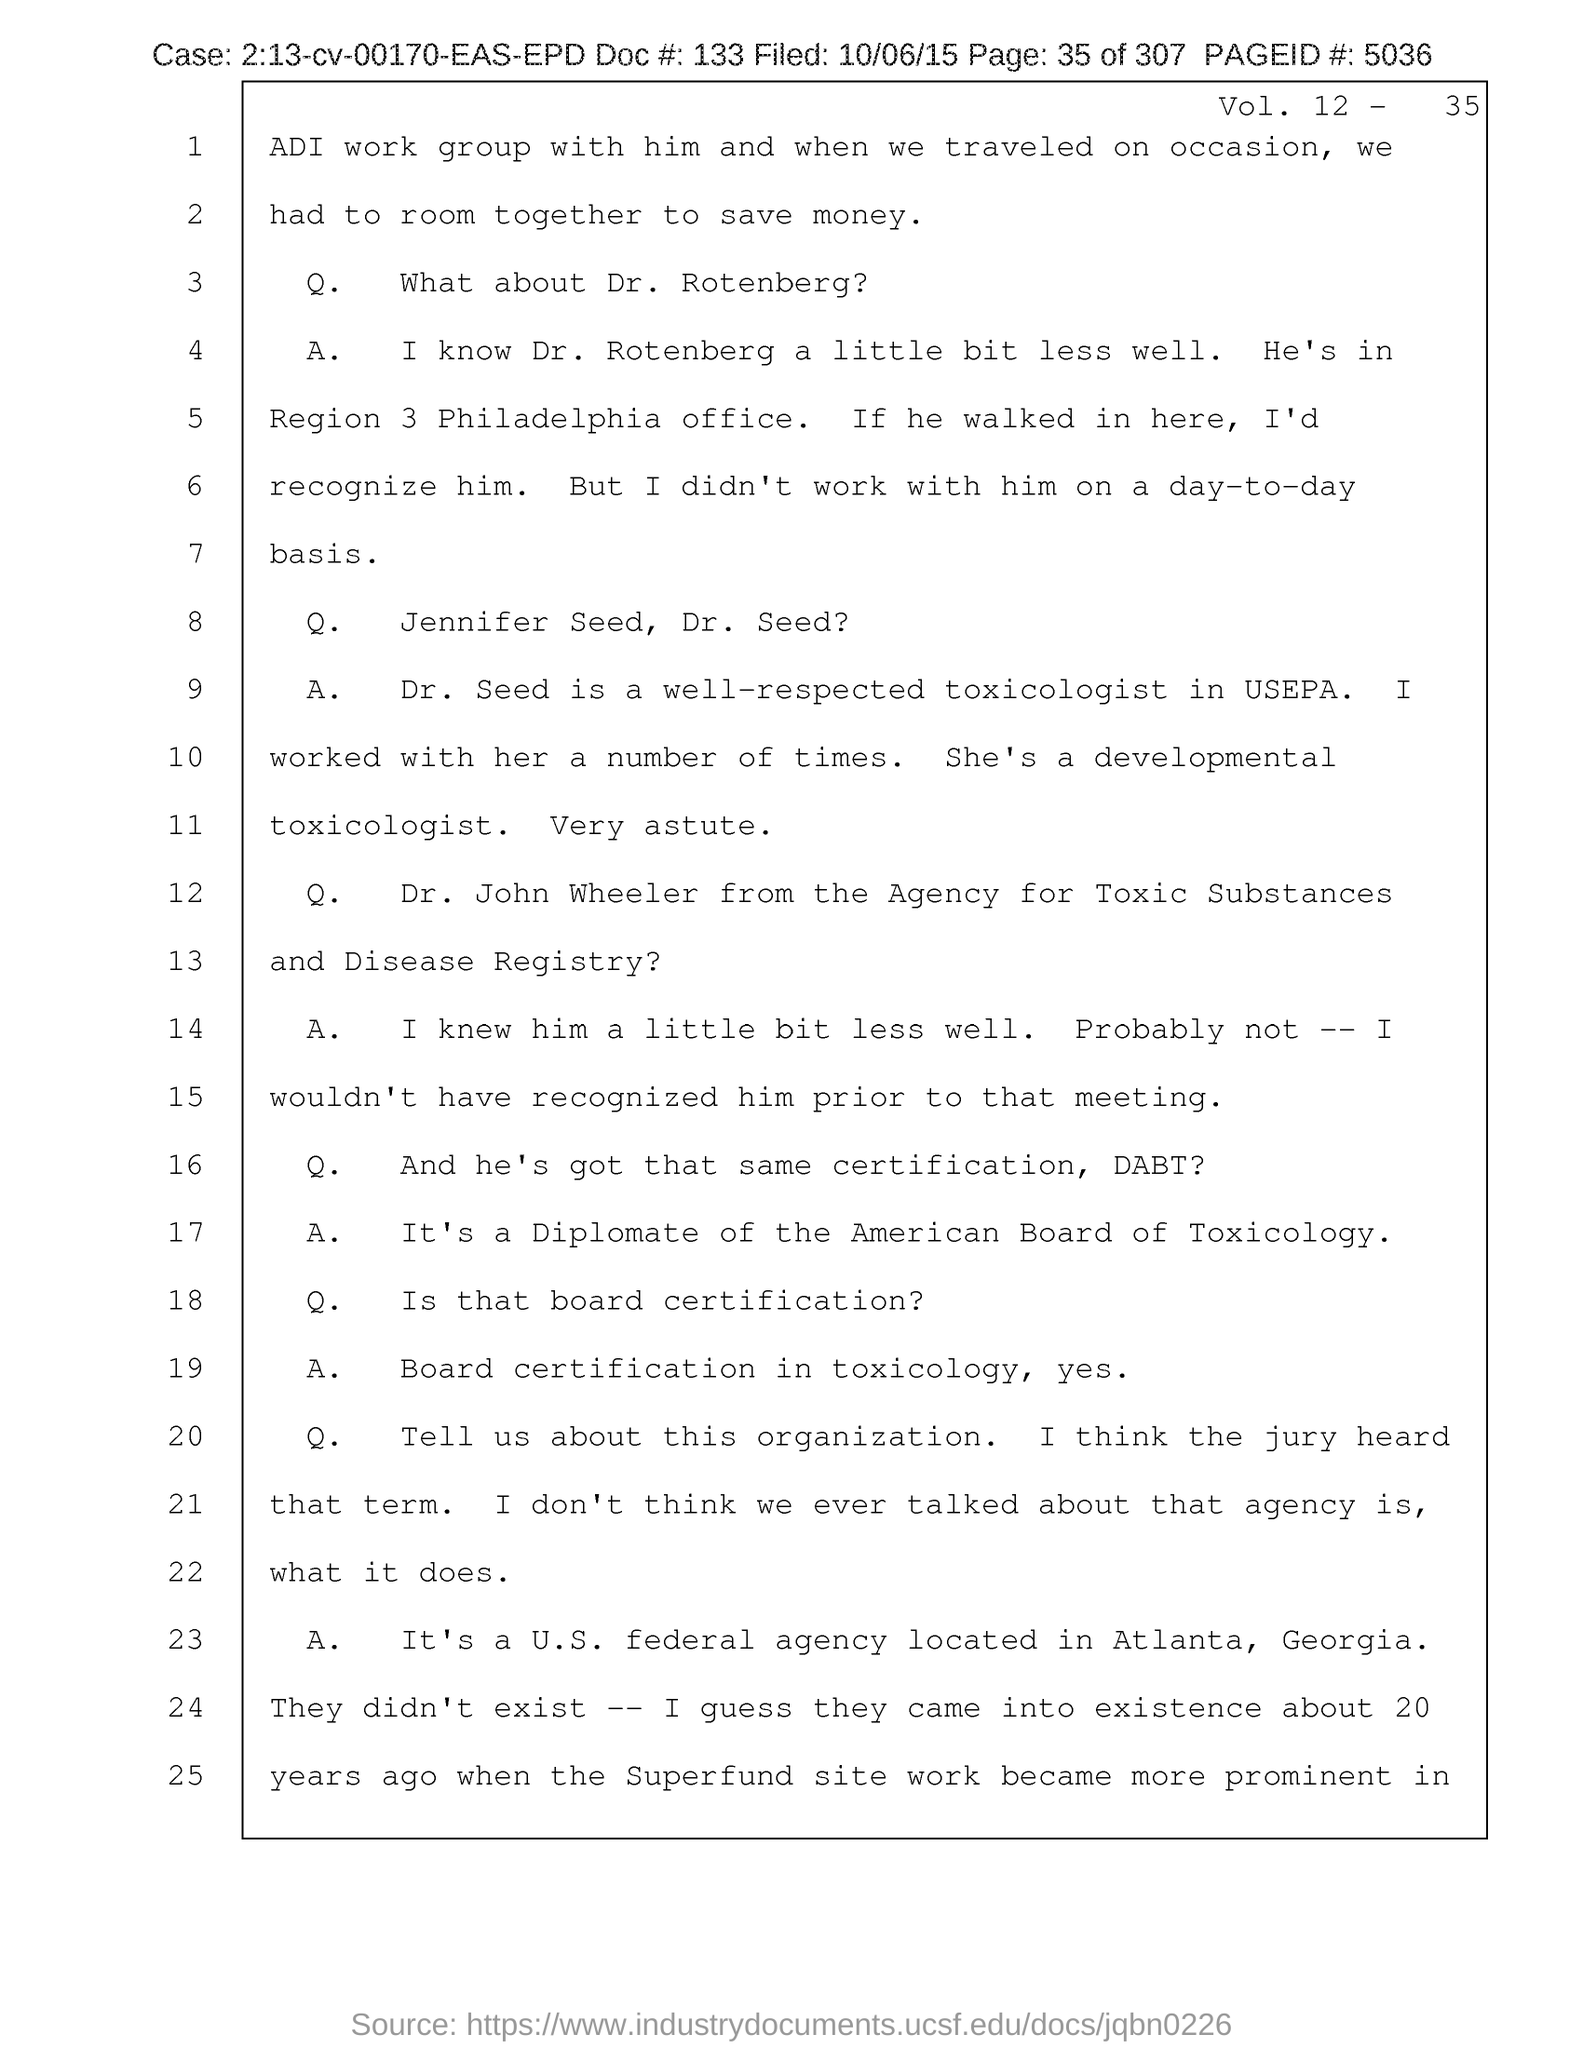Draw attention to some important aspects in this diagram. The filed date of the document is October 6, 2015. The document provides a doc # of 133. The Page ID mentioned in the document is 5036. What is the case number mentioned in the document? It is 2:13-cv-00170-EAS-EPD.. The page number mentioned in this document is 35 out of 307. 